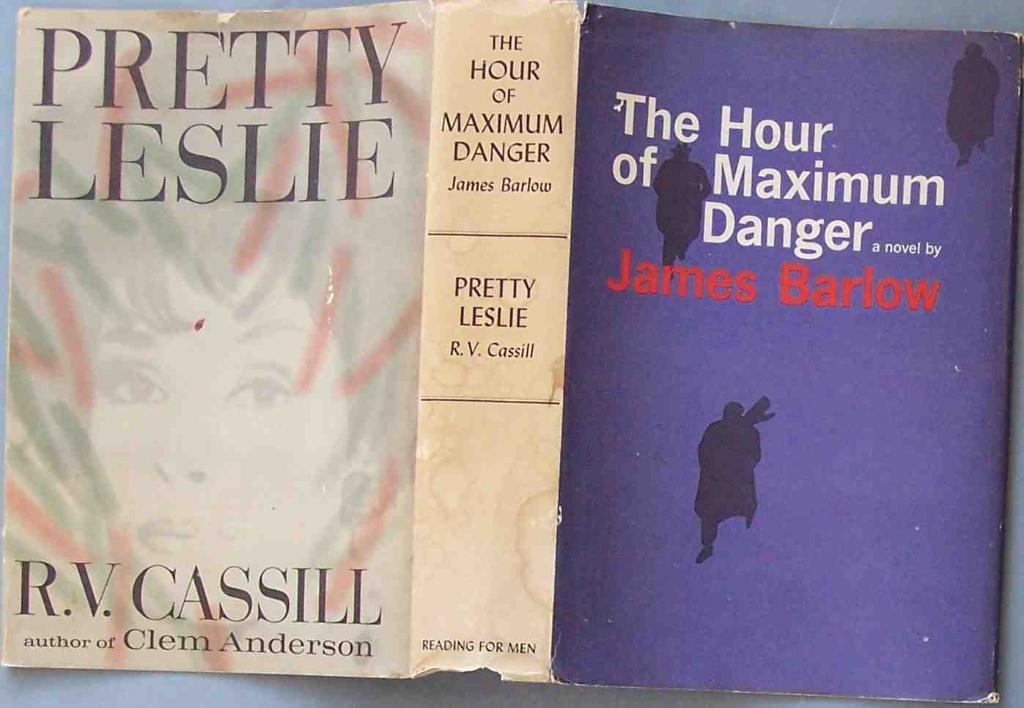Who wrote that book?
Provide a short and direct response. James barlow. What book did r.v. cassill author, other than pretty leslie?
Offer a terse response. Clem anderson. 